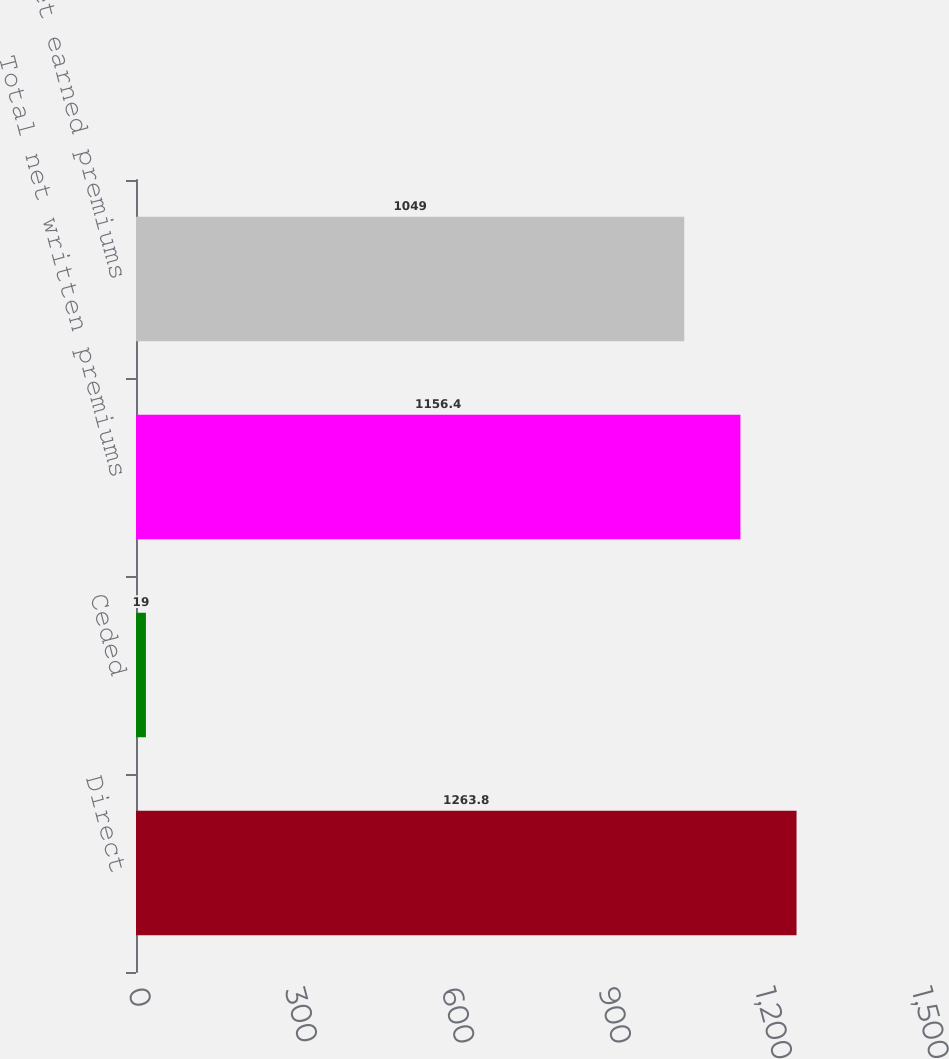Convert chart to OTSL. <chart><loc_0><loc_0><loc_500><loc_500><bar_chart><fcel>Direct<fcel>Ceded<fcel>Total net written premiums<fcel>Total net earned premiums<nl><fcel>1263.8<fcel>19<fcel>1156.4<fcel>1049<nl></chart> 